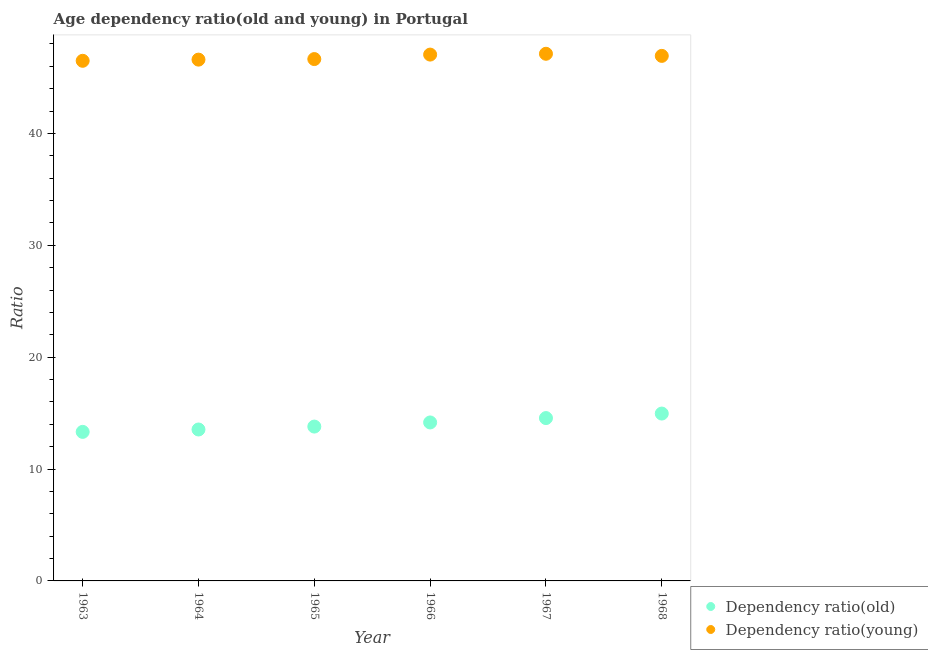How many different coloured dotlines are there?
Your answer should be compact. 2. What is the age dependency ratio(young) in 1967?
Provide a short and direct response. 47.12. Across all years, what is the maximum age dependency ratio(old)?
Provide a short and direct response. 14.96. Across all years, what is the minimum age dependency ratio(young)?
Keep it short and to the point. 46.5. In which year was the age dependency ratio(old) maximum?
Keep it short and to the point. 1968. In which year was the age dependency ratio(old) minimum?
Your answer should be compact. 1963. What is the total age dependency ratio(old) in the graph?
Ensure brevity in your answer.  84.34. What is the difference between the age dependency ratio(old) in 1964 and that in 1965?
Make the answer very short. -0.26. What is the difference between the age dependency ratio(old) in 1965 and the age dependency ratio(young) in 1964?
Your response must be concise. -32.8. What is the average age dependency ratio(old) per year?
Make the answer very short. 14.06. In the year 1968, what is the difference between the age dependency ratio(old) and age dependency ratio(young)?
Your response must be concise. -31.98. In how many years, is the age dependency ratio(young) greater than 36?
Ensure brevity in your answer.  6. What is the ratio of the age dependency ratio(old) in 1963 to that in 1966?
Your answer should be very brief. 0.94. Is the age dependency ratio(young) in 1964 less than that in 1966?
Give a very brief answer. Yes. Is the difference between the age dependency ratio(old) in 1963 and 1968 greater than the difference between the age dependency ratio(young) in 1963 and 1968?
Offer a very short reply. No. What is the difference between the highest and the second highest age dependency ratio(young)?
Keep it short and to the point. 0.07. What is the difference between the highest and the lowest age dependency ratio(old)?
Keep it short and to the point. 1.64. In how many years, is the age dependency ratio(old) greater than the average age dependency ratio(old) taken over all years?
Keep it short and to the point. 3. Does the age dependency ratio(old) monotonically increase over the years?
Give a very brief answer. Yes. Is the age dependency ratio(old) strictly greater than the age dependency ratio(young) over the years?
Keep it short and to the point. No. Is the age dependency ratio(old) strictly less than the age dependency ratio(young) over the years?
Provide a succinct answer. Yes. How many years are there in the graph?
Offer a very short reply. 6. Where does the legend appear in the graph?
Your response must be concise. Bottom right. How many legend labels are there?
Give a very brief answer. 2. How are the legend labels stacked?
Provide a short and direct response. Vertical. What is the title of the graph?
Provide a short and direct response. Age dependency ratio(old and young) in Portugal. What is the label or title of the Y-axis?
Ensure brevity in your answer.  Ratio. What is the Ratio of Dependency ratio(old) in 1963?
Give a very brief answer. 13.32. What is the Ratio in Dependency ratio(young) in 1963?
Give a very brief answer. 46.5. What is the Ratio of Dependency ratio(old) in 1964?
Keep it short and to the point. 13.54. What is the Ratio in Dependency ratio(young) in 1964?
Make the answer very short. 46.6. What is the Ratio of Dependency ratio(old) in 1965?
Offer a very short reply. 13.8. What is the Ratio of Dependency ratio(young) in 1965?
Offer a very short reply. 46.65. What is the Ratio in Dependency ratio(old) in 1966?
Keep it short and to the point. 14.17. What is the Ratio of Dependency ratio(young) in 1966?
Offer a terse response. 47.05. What is the Ratio of Dependency ratio(old) in 1967?
Give a very brief answer. 14.56. What is the Ratio of Dependency ratio(young) in 1967?
Give a very brief answer. 47.12. What is the Ratio in Dependency ratio(old) in 1968?
Your response must be concise. 14.96. What is the Ratio in Dependency ratio(young) in 1968?
Keep it short and to the point. 46.94. Across all years, what is the maximum Ratio of Dependency ratio(old)?
Ensure brevity in your answer.  14.96. Across all years, what is the maximum Ratio of Dependency ratio(young)?
Keep it short and to the point. 47.12. Across all years, what is the minimum Ratio of Dependency ratio(old)?
Make the answer very short. 13.32. Across all years, what is the minimum Ratio in Dependency ratio(young)?
Ensure brevity in your answer.  46.5. What is the total Ratio of Dependency ratio(old) in the graph?
Give a very brief answer. 84.34. What is the total Ratio in Dependency ratio(young) in the graph?
Your answer should be very brief. 280.87. What is the difference between the Ratio of Dependency ratio(old) in 1963 and that in 1964?
Provide a succinct answer. -0.21. What is the difference between the Ratio of Dependency ratio(young) in 1963 and that in 1964?
Give a very brief answer. -0.11. What is the difference between the Ratio of Dependency ratio(old) in 1963 and that in 1965?
Provide a short and direct response. -0.47. What is the difference between the Ratio in Dependency ratio(young) in 1963 and that in 1965?
Give a very brief answer. -0.15. What is the difference between the Ratio of Dependency ratio(old) in 1963 and that in 1966?
Keep it short and to the point. -0.84. What is the difference between the Ratio of Dependency ratio(young) in 1963 and that in 1966?
Offer a terse response. -0.56. What is the difference between the Ratio of Dependency ratio(old) in 1963 and that in 1967?
Your answer should be very brief. -1.23. What is the difference between the Ratio of Dependency ratio(young) in 1963 and that in 1967?
Offer a terse response. -0.63. What is the difference between the Ratio in Dependency ratio(old) in 1963 and that in 1968?
Give a very brief answer. -1.64. What is the difference between the Ratio in Dependency ratio(young) in 1963 and that in 1968?
Offer a very short reply. -0.44. What is the difference between the Ratio of Dependency ratio(old) in 1964 and that in 1965?
Offer a very short reply. -0.26. What is the difference between the Ratio of Dependency ratio(young) in 1964 and that in 1965?
Offer a very short reply. -0.05. What is the difference between the Ratio of Dependency ratio(old) in 1964 and that in 1966?
Provide a succinct answer. -0.63. What is the difference between the Ratio of Dependency ratio(young) in 1964 and that in 1966?
Your response must be concise. -0.45. What is the difference between the Ratio in Dependency ratio(old) in 1964 and that in 1967?
Your answer should be compact. -1.02. What is the difference between the Ratio in Dependency ratio(young) in 1964 and that in 1967?
Offer a terse response. -0.52. What is the difference between the Ratio in Dependency ratio(old) in 1964 and that in 1968?
Your answer should be compact. -1.42. What is the difference between the Ratio in Dependency ratio(young) in 1964 and that in 1968?
Your answer should be compact. -0.33. What is the difference between the Ratio in Dependency ratio(old) in 1965 and that in 1966?
Give a very brief answer. -0.37. What is the difference between the Ratio in Dependency ratio(young) in 1965 and that in 1966?
Offer a very short reply. -0.4. What is the difference between the Ratio of Dependency ratio(old) in 1965 and that in 1967?
Provide a succinct answer. -0.76. What is the difference between the Ratio in Dependency ratio(young) in 1965 and that in 1967?
Your response must be concise. -0.47. What is the difference between the Ratio in Dependency ratio(old) in 1965 and that in 1968?
Provide a short and direct response. -1.16. What is the difference between the Ratio in Dependency ratio(young) in 1965 and that in 1968?
Make the answer very short. -0.28. What is the difference between the Ratio in Dependency ratio(old) in 1966 and that in 1967?
Your response must be concise. -0.39. What is the difference between the Ratio of Dependency ratio(young) in 1966 and that in 1967?
Give a very brief answer. -0.07. What is the difference between the Ratio in Dependency ratio(old) in 1966 and that in 1968?
Offer a very short reply. -0.79. What is the difference between the Ratio in Dependency ratio(young) in 1966 and that in 1968?
Provide a short and direct response. 0.12. What is the difference between the Ratio in Dependency ratio(old) in 1967 and that in 1968?
Provide a short and direct response. -0.4. What is the difference between the Ratio in Dependency ratio(young) in 1967 and that in 1968?
Offer a terse response. 0.19. What is the difference between the Ratio in Dependency ratio(old) in 1963 and the Ratio in Dependency ratio(young) in 1964?
Make the answer very short. -33.28. What is the difference between the Ratio in Dependency ratio(old) in 1963 and the Ratio in Dependency ratio(young) in 1965?
Offer a very short reply. -33.33. What is the difference between the Ratio in Dependency ratio(old) in 1963 and the Ratio in Dependency ratio(young) in 1966?
Offer a terse response. -33.73. What is the difference between the Ratio of Dependency ratio(old) in 1963 and the Ratio of Dependency ratio(young) in 1967?
Your answer should be very brief. -33.8. What is the difference between the Ratio of Dependency ratio(old) in 1963 and the Ratio of Dependency ratio(young) in 1968?
Keep it short and to the point. -33.61. What is the difference between the Ratio of Dependency ratio(old) in 1964 and the Ratio of Dependency ratio(young) in 1965?
Offer a very short reply. -33.11. What is the difference between the Ratio of Dependency ratio(old) in 1964 and the Ratio of Dependency ratio(young) in 1966?
Provide a succinct answer. -33.52. What is the difference between the Ratio of Dependency ratio(old) in 1964 and the Ratio of Dependency ratio(young) in 1967?
Give a very brief answer. -33.59. What is the difference between the Ratio in Dependency ratio(old) in 1964 and the Ratio in Dependency ratio(young) in 1968?
Provide a succinct answer. -33.4. What is the difference between the Ratio in Dependency ratio(old) in 1965 and the Ratio in Dependency ratio(young) in 1966?
Keep it short and to the point. -33.25. What is the difference between the Ratio of Dependency ratio(old) in 1965 and the Ratio of Dependency ratio(young) in 1967?
Provide a succinct answer. -33.33. What is the difference between the Ratio of Dependency ratio(old) in 1965 and the Ratio of Dependency ratio(young) in 1968?
Offer a terse response. -33.14. What is the difference between the Ratio of Dependency ratio(old) in 1966 and the Ratio of Dependency ratio(young) in 1967?
Make the answer very short. -32.96. What is the difference between the Ratio of Dependency ratio(old) in 1966 and the Ratio of Dependency ratio(young) in 1968?
Provide a succinct answer. -32.77. What is the difference between the Ratio of Dependency ratio(old) in 1967 and the Ratio of Dependency ratio(young) in 1968?
Ensure brevity in your answer.  -32.38. What is the average Ratio in Dependency ratio(old) per year?
Provide a short and direct response. 14.06. What is the average Ratio of Dependency ratio(young) per year?
Your response must be concise. 46.81. In the year 1963, what is the difference between the Ratio in Dependency ratio(old) and Ratio in Dependency ratio(young)?
Your answer should be very brief. -33.17. In the year 1964, what is the difference between the Ratio in Dependency ratio(old) and Ratio in Dependency ratio(young)?
Provide a short and direct response. -33.06. In the year 1965, what is the difference between the Ratio of Dependency ratio(old) and Ratio of Dependency ratio(young)?
Your response must be concise. -32.85. In the year 1966, what is the difference between the Ratio of Dependency ratio(old) and Ratio of Dependency ratio(young)?
Provide a succinct answer. -32.89. In the year 1967, what is the difference between the Ratio in Dependency ratio(old) and Ratio in Dependency ratio(young)?
Ensure brevity in your answer.  -32.57. In the year 1968, what is the difference between the Ratio in Dependency ratio(old) and Ratio in Dependency ratio(young)?
Your answer should be very brief. -31.98. What is the ratio of the Ratio in Dependency ratio(old) in 1963 to that in 1964?
Provide a succinct answer. 0.98. What is the ratio of the Ratio in Dependency ratio(old) in 1963 to that in 1965?
Offer a terse response. 0.97. What is the ratio of the Ratio in Dependency ratio(old) in 1963 to that in 1966?
Offer a very short reply. 0.94. What is the ratio of the Ratio in Dependency ratio(old) in 1963 to that in 1967?
Give a very brief answer. 0.92. What is the ratio of the Ratio in Dependency ratio(young) in 1963 to that in 1967?
Provide a succinct answer. 0.99. What is the ratio of the Ratio in Dependency ratio(old) in 1963 to that in 1968?
Make the answer very short. 0.89. What is the ratio of the Ratio of Dependency ratio(young) in 1963 to that in 1968?
Offer a terse response. 0.99. What is the ratio of the Ratio in Dependency ratio(old) in 1964 to that in 1965?
Ensure brevity in your answer.  0.98. What is the ratio of the Ratio in Dependency ratio(old) in 1964 to that in 1966?
Offer a terse response. 0.96. What is the ratio of the Ratio in Dependency ratio(old) in 1964 to that in 1967?
Your response must be concise. 0.93. What is the ratio of the Ratio in Dependency ratio(young) in 1964 to that in 1967?
Offer a terse response. 0.99. What is the ratio of the Ratio of Dependency ratio(old) in 1964 to that in 1968?
Your answer should be compact. 0.9. What is the ratio of the Ratio of Dependency ratio(young) in 1964 to that in 1968?
Your response must be concise. 0.99. What is the ratio of the Ratio in Dependency ratio(old) in 1965 to that in 1967?
Offer a very short reply. 0.95. What is the ratio of the Ratio in Dependency ratio(old) in 1965 to that in 1968?
Your answer should be very brief. 0.92. What is the ratio of the Ratio of Dependency ratio(old) in 1966 to that in 1967?
Your answer should be very brief. 0.97. What is the ratio of the Ratio in Dependency ratio(old) in 1966 to that in 1968?
Provide a succinct answer. 0.95. What is the ratio of the Ratio in Dependency ratio(young) in 1966 to that in 1968?
Your answer should be very brief. 1. What is the difference between the highest and the second highest Ratio of Dependency ratio(old)?
Ensure brevity in your answer.  0.4. What is the difference between the highest and the second highest Ratio of Dependency ratio(young)?
Provide a succinct answer. 0.07. What is the difference between the highest and the lowest Ratio of Dependency ratio(old)?
Ensure brevity in your answer.  1.64. What is the difference between the highest and the lowest Ratio of Dependency ratio(young)?
Provide a short and direct response. 0.63. 